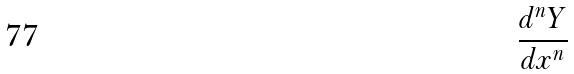Convert formula to latex. <formula><loc_0><loc_0><loc_500><loc_500>\frac { d ^ { n } Y } { d x ^ { n } }</formula> 